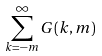<formula> <loc_0><loc_0><loc_500><loc_500>\sum _ { k = - m } ^ { \infty } G ( k , m )</formula> 